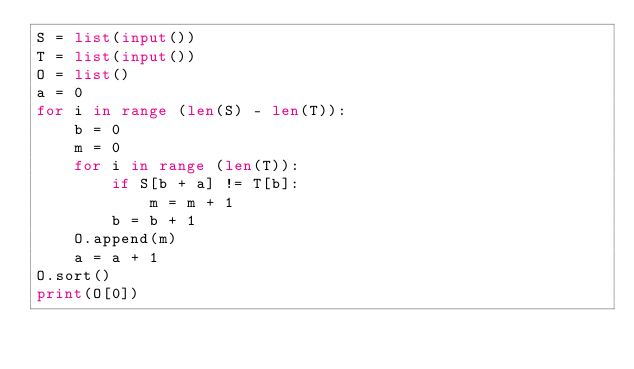Convert code to text. <code><loc_0><loc_0><loc_500><loc_500><_Python_>S = list(input())
T = list(input())
O = list()
a = 0
for i in range (len(S) - len(T)):
    b = 0
    m = 0
    for i in range (len(T)):
        if S[b + a] != T[b]:
            m = m + 1
        b = b + 1
    O.append(m)
    a = a + 1
O.sort()
print(O[0])</code> 